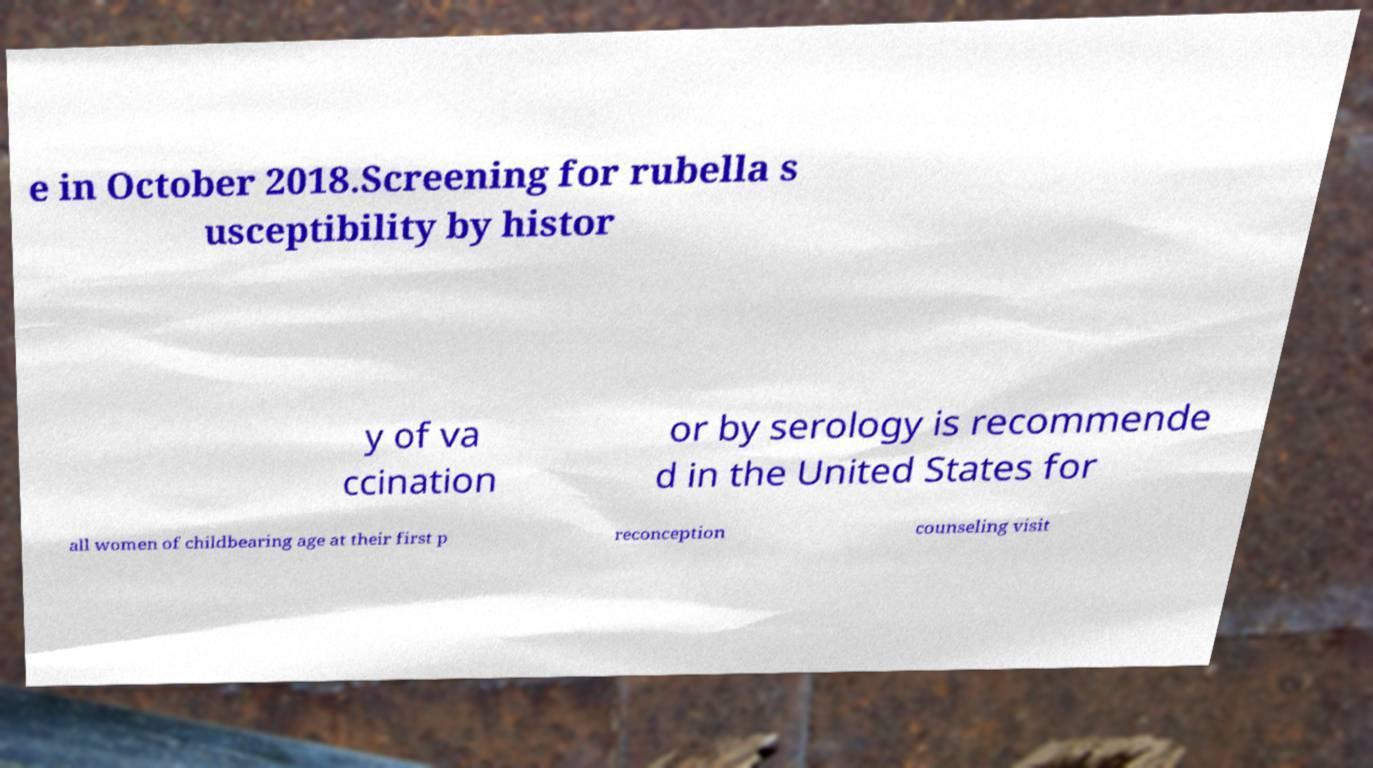Could you extract and type out the text from this image? e in October 2018.Screening for rubella s usceptibility by histor y of va ccination or by serology is recommende d in the United States for all women of childbearing age at their first p reconception counseling visit 